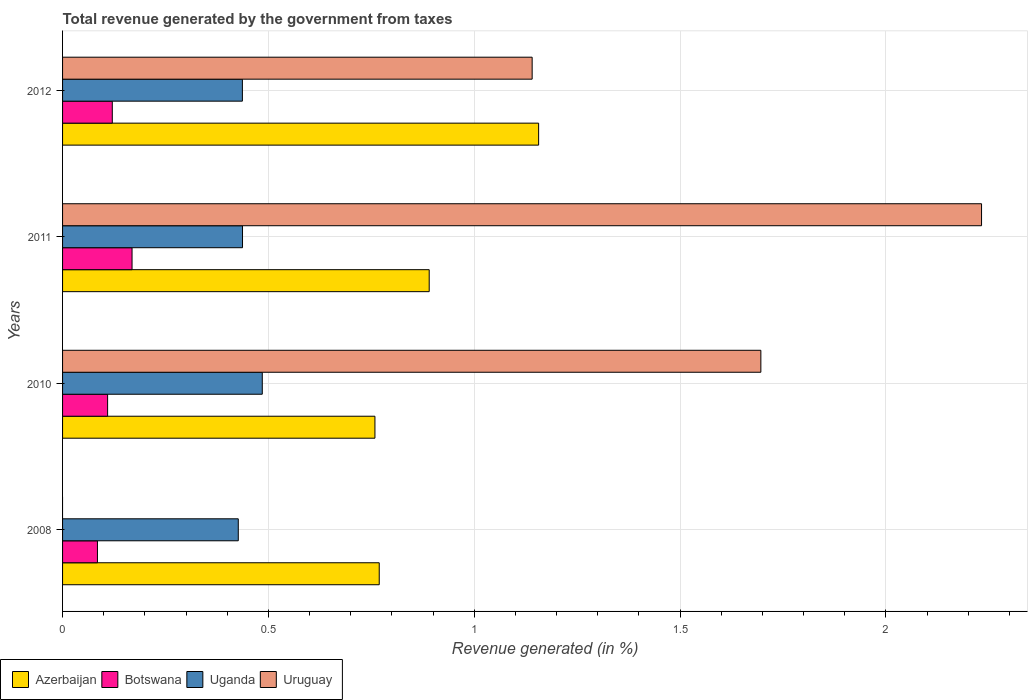Are the number of bars on each tick of the Y-axis equal?
Ensure brevity in your answer.  No. How many bars are there on the 2nd tick from the bottom?
Keep it short and to the point. 4. What is the total revenue generated in Azerbaijan in 2012?
Your answer should be compact. 1.16. Across all years, what is the maximum total revenue generated in Uganda?
Provide a succinct answer. 0.49. Across all years, what is the minimum total revenue generated in Botswana?
Ensure brevity in your answer.  0.08. In which year was the total revenue generated in Uruguay maximum?
Ensure brevity in your answer.  2011. What is the total total revenue generated in Azerbaijan in the graph?
Offer a very short reply. 3.57. What is the difference between the total revenue generated in Uganda in 2008 and that in 2011?
Give a very brief answer. -0.01. What is the difference between the total revenue generated in Azerbaijan in 2010 and the total revenue generated in Uganda in 2008?
Provide a succinct answer. 0.33. What is the average total revenue generated in Uruguay per year?
Your answer should be very brief. 1.27. In the year 2011, what is the difference between the total revenue generated in Uganda and total revenue generated in Botswana?
Make the answer very short. 0.27. In how many years, is the total revenue generated in Uruguay greater than 2.1 %?
Your answer should be very brief. 1. What is the ratio of the total revenue generated in Azerbaijan in 2008 to that in 2011?
Ensure brevity in your answer.  0.86. Is the difference between the total revenue generated in Uganda in 2008 and 2012 greater than the difference between the total revenue generated in Botswana in 2008 and 2012?
Offer a terse response. Yes. What is the difference between the highest and the second highest total revenue generated in Azerbaijan?
Your response must be concise. 0.27. What is the difference between the highest and the lowest total revenue generated in Botswana?
Your answer should be compact. 0.08. In how many years, is the total revenue generated in Botswana greater than the average total revenue generated in Botswana taken over all years?
Offer a terse response. 1. Is it the case that in every year, the sum of the total revenue generated in Azerbaijan and total revenue generated in Botswana is greater than the sum of total revenue generated in Uruguay and total revenue generated in Uganda?
Offer a terse response. Yes. Is it the case that in every year, the sum of the total revenue generated in Botswana and total revenue generated in Azerbaijan is greater than the total revenue generated in Uruguay?
Your answer should be compact. No. How many bars are there?
Offer a terse response. 15. Are all the bars in the graph horizontal?
Offer a very short reply. Yes. Does the graph contain any zero values?
Your answer should be very brief. Yes. Does the graph contain grids?
Provide a short and direct response. Yes. Where does the legend appear in the graph?
Your answer should be very brief. Bottom left. How many legend labels are there?
Offer a very short reply. 4. How are the legend labels stacked?
Offer a terse response. Horizontal. What is the title of the graph?
Give a very brief answer. Total revenue generated by the government from taxes. Does "United States" appear as one of the legend labels in the graph?
Your answer should be very brief. No. What is the label or title of the X-axis?
Keep it short and to the point. Revenue generated (in %). What is the Revenue generated (in %) in Azerbaijan in 2008?
Keep it short and to the point. 0.77. What is the Revenue generated (in %) of Botswana in 2008?
Your answer should be compact. 0.08. What is the Revenue generated (in %) of Uganda in 2008?
Ensure brevity in your answer.  0.43. What is the Revenue generated (in %) in Uruguay in 2008?
Provide a succinct answer. 0. What is the Revenue generated (in %) of Azerbaijan in 2010?
Provide a short and direct response. 0.76. What is the Revenue generated (in %) in Botswana in 2010?
Make the answer very short. 0.11. What is the Revenue generated (in %) of Uganda in 2010?
Offer a very short reply. 0.49. What is the Revenue generated (in %) in Uruguay in 2010?
Provide a succinct answer. 1.7. What is the Revenue generated (in %) in Azerbaijan in 2011?
Offer a very short reply. 0.89. What is the Revenue generated (in %) of Botswana in 2011?
Provide a succinct answer. 0.17. What is the Revenue generated (in %) of Uganda in 2011?
Offer a very short reply. 0.44. What is the Revenue generated (in %) of Uruguay in 2011?
Keep it short and to the point. 2.23. What is the Revenue generated (in %) of Azerbaijan in 2012?
Your response must be concise. 1.16. What is the Revenue generated (in %) in Botswana in 2012?
Your answer should be very brief. 0.12. What is the Revenue generated (in %) in Uganda in 2012?
Your response must be concise. 0.44. What is the Revenue generated (in %) in Uruguay in 2012?
Your answer should be compact. 1.14. Across all years, what is the maximum Revenue generated (in %) in Azerbaijan?
Keep it short and to the point. 1.16. Across all years, what is the maximum Revenue generated (in %) of Botswana?
Make the answer very short. 0.17. Across all years, what is the maximum Revenue generated (in %) in Uganda?
Your answer should be very brief. 0.49. Across all years, what is the maximum Revenue generated (in %) in Uruguay?
Offer a very short reply. 2.23. Across all years, what is the minimum Revenue generated (in %) in Azerbaijan?
Offer a terse response. 0.76. Across all years, what is the minimum Revenue generated (in %) of Botswana?
Provide a short and direct response. 0.08. Across all years, what is the minimum Revenue generated (in %) of Uganda?
Make the answer very short. 0.43. What is the total Revenue generated (in %) in Azerbaijan in the graph?
Your answer should be very brief. 3.57. What is the total Revenue generated (in %) of Botswana in the graph?
Your answer should be compact. 0.48. What is the total Revenue generated (in %) of Uganda in the graph?
Provide a succinct answer. 1.79. What is the total Revenue generated (in %) in Uruguay in the graph?
Provide a succinct answer. 5.07. What is the difference between the Revenue generated (in %) in Azerbaijan in 2008 and that in 2010?
Provide a short and direct response. 0.01. What is the difference between the Revenue generated (in %) in Botswana in 2008 and that in 2010?
Offer a very short reply. -0.02. What is the difference between the Revenue generated (in %) in Uganda in 2008 and that in 2010?
Your response must be concise. -0.06. What is the difference between the Revenue generated (in %) of Azerbaijan in 2008 and that in 2011?
Give a very brief answer. -0.12. What is the difference between the Revenue generated (in %) in Botswana in 2008 and that in 2011?
Offer a very short reply. -0.08. What is the difference between the Revenue generated (in %) in Uganda in 2008 and that in 2011?
Provide a short and direct response. -0.01. What is the difference between the Revenue generated (in %) in Azerbaijan in 2008 and that in 2012?
Provide a short and direct response. -0.39. What is the difference between the Revenue generated (in %) of Botswana in 2008 and that in 2012?
Ensure brevity in your answer.  -0.04. What is the difference between the Revenue generated (in %) of Uganda in 2008 and that in 2012?
Provide a succinct answer. -0.01. What is the difference between the Revenue generated (in %) of Azerbaijan in 2010 and that in 2011?
Provide a succinct answer. -0.13. What is the difference between the Revenue generated (in %) of Botswana in 2010 and that in 2011?
Make the answer very short. -0.06. What is the difference between the Revenue generated (in %) of Uganda in 2010 and that in 2011?
Make the answer very short. 0.05. What is the difference between the Revenue generated (in %) in Uruguay in 2010 and that in 2011?
Offer a very short reply. -0.54. What is the difference between the Revenue generated (in %) in Azerbaijan in 2010 and that in 2012?
Your answer should be very brief. -0.4. What is the difference between the Revenue generated (in %) of Botswana in 2010 and that in 2012?
Provide a short and direct response. -0.01. What is the difference between the Revenue generated (in %) in Uganda in 2010 and that in 2012?
Make the answer very short. 0.05. What is the difference between the Revenue generated (in %) of Uruguay in 2010 and that in 2012?
Keep it short and to the point. 0.56. What is the difference between the Revenue generated (in %) in Azerbaijan in 2011 and that in 2012?
Offer a very short reply. -0.27. What is the difference between the Revenue generated (in %) of Botswana in 2011 and that in 2012?
Provide a short and direct response. 0.05. What is the difference between the Revenue generated (in %) in Uganda in 2011 and that in 2012?
Make the answer very short. 0. What is the difference between the Revenue generated (in %) of Uruguay in 2011 and that in 2012?
Give a very brief answer. 1.09. What is the difference between the Revenue generated (in %) in Azerbaijan in 2008 and the Revenue generated (in %) in Botswana in 2010?
Give a very brief answer. 0.66. What is the difference between the Revenue generated (in %) of Azerbaijan in 2008 and the Revenue generated (in %) of Uganda in 2010?
Your answer should be compact. 0.28. What is the difference between the Revenue generated (in %) in Azerbaijan in 2008 and the Revenue generated (in %) in Uruguay in 2010?
Your answer should be compact. -0.93. What is the difference between the Revenue generated (in %) in Botswana in 2008 and the Revenue generated (in %) in Uganda in 2010?
Provide a succinct answer. -0.4. What is the difference between the Revenue generated (in %) of Botswana in 2008 and the Revenue generated (in %) of Uruguay in 2010?
Provide a succinct answer. -1.61. What is the difference between the Revenue generated (in %) of Uganda in 2008 and the Revenue generated (in %) of Uruguay in 2010?
Ensure brevity in your answer.  -1.27. What is the difference between the Revenue generated (in %) of Azerbaijan in 2008 and the Revenue generated (in %) of Botswana in 2011?
Make the answer very short. 0.6. What is the difference between the Revenue generated (in %) in Azerbaijan in 2008 and the Revenue generated (in %) in Uganda in 2011?
Your response must be concise. 0.33. What is the difference between the Revenue generated (in %) of Azerbaijan in 2008 and the Revenue generated (in %) of Uruguay in 2011?
Provide a short and direct response. -1.46. What is the difference between the Revenue generated (in %) of Botswana in 2008 and the Revenue generated (in %) of Uganda in 2011?
Make the answer very short. -0.35. What is the difference between the Revenue generated (in %) of Botswana in 2008 and the Revenue generated (in %) of Uruguay in 2011?
Your response must be concise. -2.15. What is the difference between the Revenue generated (in %) of Uganda in 2008 and the Revenue generated (in %) of Uruguay in 2011?
Offer a very short reply. -1.81. What is the difference between the Revenue generated (in %) in Azerbaijan in 2008 and the Revenue generated (in %) in Botswana in 2012?
Make the answer very short. 0.65. What is the difference between the Revenue generated (in %) in Azerbaijan in 2008 and the Revenue generated (in %) in Uganda in 2012?
Provide a succinct answer. 0.33. What is the difference between the Revenue generated (in %) in Azerbaijan in 2008 and the Revenue generated (in %) in Uruguay in 2012?
Your answer should be compact. -0.37. What is the difference between the Revenue generated (in %) in Botswana in 2008 and the Revenue generated (in %) in Uganda in 2012?
Provide a short and direct response. -0.35. What is the difference between the Revenue generated (in %) in Botswana in 2008 and the Revenue generated (in %) in Uruguay in 2012?
Offer a very short reply. -1.06. What is the difference between the Revenue generated (in %) of Uganda in 2008 and the Revenue generated (in %) of Uruguay in 2012?
Your answer should be very brief. -0.71. What is the difference between the Revenue generated (in %) in Azerbaijan in 2010 and the Revenue generated (in %) in Botswana in 2011?
Your answer should be compact. 0.59. What is the difference between the Revenue generated (in %) of Azerbaijan in 2010 and the Revenue generated (in %) of Uganda in 2011?
Your answer should be compact. 0.32. What is the difference between the Revenue generated (in %) in Azerbaijan in 2010 and the Revenue generated (in %) in Uruguay in 2011?
Give a very brief answer. -1.47. What is the difference between the Revenue generated (in %) of Botswana in 2010 and the Revenue generated (in %) of Uganda in 2011?
Your answer should be compact. -0.33. What is the difference between the Revenue generated (in %) of Botswana in 2010 and the Revenue generated (in %) of Uruguay in 2011?
Provide a short and direct response. -2.12. What is the difference between the Revenue generated (in %) in Uganda in 2010 and the Revenue generated (in %) in Uruguay in 2011?
Your answer should be compact. -1.75. What is the difference between the Revenue generated (in %) of Azerbaijan in 2010 and the Revenue generated (in %) of Botswana in 2012?
Offer a very short reply. 0.64. What is the difference between the Revenue generated (in %) in Azerbaijan in 2010 and the Revenue generated (in %) in Uganda in 2012?
Your answer should be compact. 0.32. What is the difference between the Revenue generated (in %) in Azerbaijan in 2010 and the Revenue generated (in %) in Uruguay in 2012?
Offer a very short reply. -0.38. What is the difference between the Revenue generated (in %) in Botswana in 2010 and the Revenue generated (in %) in Uganda in 2012?
Your response must be concise. -0.33. What is the difference between the Revenue generated (in %) of Botswana in 2010 and the Revenue generated (in %) of Uruguay in 2012?
Provide a succinct answer. -1.03. What is the difference between the Revenue generated (in %) of Uganda in 2010 and the Revenue generated (in %) of Uruguay in 2012?
Your response must be concise. -0.66. What is the difference between the Revenue generated (in %) of Azerbaijan in 2011 and the Revenue generated (in %) of Botswana in 2012?
Provide a succinct answer. 0.77. What is the difference between the Revenue generated (in %) in Azerbaijan in 2011 and the Revenue generated (in %) in Uganda in 2012?
Keep it short and to the point. 0.45. What is the difference between the Revenue generated (in %) of Azerbaijan in 2011 and the Revenue generated (in %) of Uruguay in 2012?
Provide a succinct answer. -0.25. What is the difference between the Revenue generated (in %) of Botswana in 2011 and the Revenue generated (in %) of Uganda in 2012?
Offer a very short reply. -0.27. What is the difference between the Revenue generated (in %) of Botswana in 2011 and the Revenue generated (in %) of Uruguay in 2012?
Your response must be concise. -0.97. What is the difference between the Revenue generated (in %) in Uganda in 2011 and the Revenue generated (in %) in Uruguay in 2012?
Make the answer very short. -0.7. What is the average Revenue generated (in %) of Azerbaijan per year?
Give a very brief answer. 0.89. What is the average Revenue generated (in %) of Botswana per year?
Provide a succinct answer. 0.12. What is the average Revenue generated (in %) of Uganda per year?
Offer a very short reply. 0.45. What is the average Revenue generated (in %) in Uruguay per year?
Provide a succinct answer. 1.27. In the year 2008, what is the difference between the Revenue generated (in %) of Azerbaijan and Revenue generated (in %) of Botswana?
Keep it short and to the point. 0.68. In the year 2008, what is the difference between the Revenue generated (in %) of Azerbaijan and Revenue generated (in %) of Uganda?
Make the answer very short. 0.34. In the year 2008, what is the difference between the Revenue generated (in %) in Botswana and Revenue generated (in %) in Uganda?
Your answer should be compact. -0.34. In the year 2010, what is the difference between the Revenue generated (in %) in Azerbaijan and Revenue generated (in %) in Botswana?
Give a very brief answer. 0.65. In the year 2010, what is the difference between the Revenue generated (in %) in Azerbaijan and Revenue generated (in %) in Uganda?
Your response must be concise. 0.27. In the year 2010, what is the difference between the Revenue generated (in %) of Azerbaijan and Revenue generated (in %) of Uruguay?
Offer a terse response. -0.94. In the year 2010, what is the difference between the Revenue generated (in %) of Botswana and Revenue generated (in %) of Uganda?
Provide a short and direct response. -0.38. In the year 2010, what is the difference between the Revenue generated (in %) of Botswana and Revenue generated (in %) of Uruguay?
Your answer should be very brief. -1.59. In the year 2010, what is the difference between the Revenue generated (in %) in Uganda and Revenue generated (in %) in Uruguay?
Your answer should be very brief. -1.21. In the year 2011, what is the difference between the Revenue generated (in %) of Azerbaijan and Revenue generated (in %) of Botswana?
Offer a very short reply. 0.72. In the year 2011, what is the difference between the Revenue generated (in %) of Azerbaijan and Revenue generated (in %) of Uganda?
Keep it short and to the point. 0.45. In the year 2011, what is the difference between the Revenue generated (in %) in Azerbaijan and Revenue generated (in %) in Uruguay?
Your response must be concise. -1.34. In the year 2011, what is the difference between the Revenue generated (in %) in Botswana and Revenue generated (in %) in Uganda?
Offer a very short reply. -0.27. In the year 2011, what is the difference between the Revenue generated (in %) of Botswana and Revenue generated (in %) of Uruguay?
Offer a terse response. -2.06. In the year 2011, what is the difference between the Revenue generated (in %) in Uganda and Revenue generated (in %) in Uruguay?
Give a very brief answer. -1.79. In the year 2012, what is the difference between the Revenue generated (in %) of Azerbaijan and Revenue generated (in %) of Botswana?
Your answer should be compact. 1.04. In the year 2012, what is the difference between the Revenue generated (in %) of Azerbaijan and Revenue generated (in %) of Uganda?
Your answer should be compact. 0.72. In the year 2012, what is the difference between the Revenue generated (in %) in Azerbaijan and Revenue generated (in %) in Uruguay?
Your answer should be very brief. 0.02. In the year 2012, what is the difference between the Revenue generated (in %) of Botswana and Revenue generated (in %) of Uganda?
Provide a short and direct response. -0.32. In the year 2012, what is the difference between the Revenue generated (in %) of Botswana and Revenue generated (in %) of Uruguay?
Your answer should be very brief. -1.02. In the year 2012, what is the difference between the Revenue generated (in %) of Uganda and Revenue generated (in %) of Uruguay?
Offer a terse response. -0.7. What is the ratio of the Revenue generated (in %) in Azerbaijan in 2008 to that in 2010?
Your answer should be very brief. 1.01. What is the ratio of the Revenue generated (in %) in Botswana in 2008 to that in 2010?
Your response must be concise. 0.77. What is the ratio of the Revenue generated (in %) in Uganda in 2008 to that in 2010?
Your answer should be very brief. 0.88. What is the ratio of the Revenue generated (in %) in Azerbaijan in 2008 to that in 2011?
Ensure brevity in your answer.  0.86. What is the ratio of the Revenue generated (in %) in Botswana in 2008 to that in 2011?
Keep it short and to the point. 0.5. What is the ratio of the Revenue generated (in %) of Uganda in 2008 to that in 2011?
Offer a terse response. 0.98. What is the ratio of the Revenue generated (in %) in Azerbaijan in 2008 to that in 2012?
Keep it short and to the point. 0.67. What is the ratio of the Revenue generated (in %) in Botswana in 2008 to that in 2012?
Make the answer very short. 0.7. What is the ratio of the Revenue generated (in %) in Uganda in 2008 to that in 2012?
Make the answer very short. 0.98. What is the ratio of the Revenue generated (in %) in Azerbaijan in 2010 to that in 2011?
Your response must be concise. 0.85. What is the ratio of the Revenue generated (in %) of Botswana in 2010 to that in 2011?
Your response must be concise. 0.65. What is the ratio of the Revenue generated (in %) in Uganda in 2010 to that in 2011?
Your answer should be compact. 1.11. What is the ratio of the Revenue generated (in %) of Uruguay in 2010 to that in 2011?
Offer a very short reply. 0.76. What is the ratio of the Revenue generated (in %) in Azerbaijan in 2010 to that in 2012?
Offer a terse response. 0.66. What is the ratio of the Revenue generated (in %) of Botswana in 2010 to that in 2012?
Keep it short and to the point. 0.91. What is the ratio of the Revenue generated (in %) of Uganda in 2010 to that in 2012?
Offer a terse response. 1.11. What is the ratio of the Revenue generated (in %) of Uruguay in 2010 to that in 2012?
Your answer should be very brief. 1.49. What is the ratio of the Revenue generated (in %) of Azerbaijan in 2011 to that in 2012?
Ensure brevity in your answer.  0.77. What is the ratio of the Revenue generated (in %) of Botswana in 2011 to that in 2012?
Ensure brevity in your answer.  1.4. What is the ratio of the Revenue generated (in %) in Uruguay in 2011 to that in 2012?
Your answer should be very brief. 1.96. What is the difference between the highest and the second highest Revenue generated (in %) of Azerbaijan?
Provide a short and direct response. 0.27. What is the difference between the highest and the second highest Revenue generated (in %) in Botswana?
Provide a succinct answer. 0.05. What is the difference between the highest and the second highest Revenue generated (in %) of Uganda?
Your answer should be compact. 0.05. What is the difference between the highest and the second highest Revenue generated (in %) in Uruguay?
Your response must be concise. 0.54. What is the difference between the highest and the lowest Revenue generated (in %) in Azerbaijan?
Give a very brief answer. 0.4. What is the difference between the highest and the lowest Revenue generated (in %) in Botswana?
Provide a succinct answer. 0.08. What is the difference between the highest and the lowest Revenue generated (in %) of Uganda?
Your answer should be compact. 0.06. What is the difference between the highest and the lowest Revenue generated (in %) of Uruguay?
Your answer should be very brief. 2.23. 